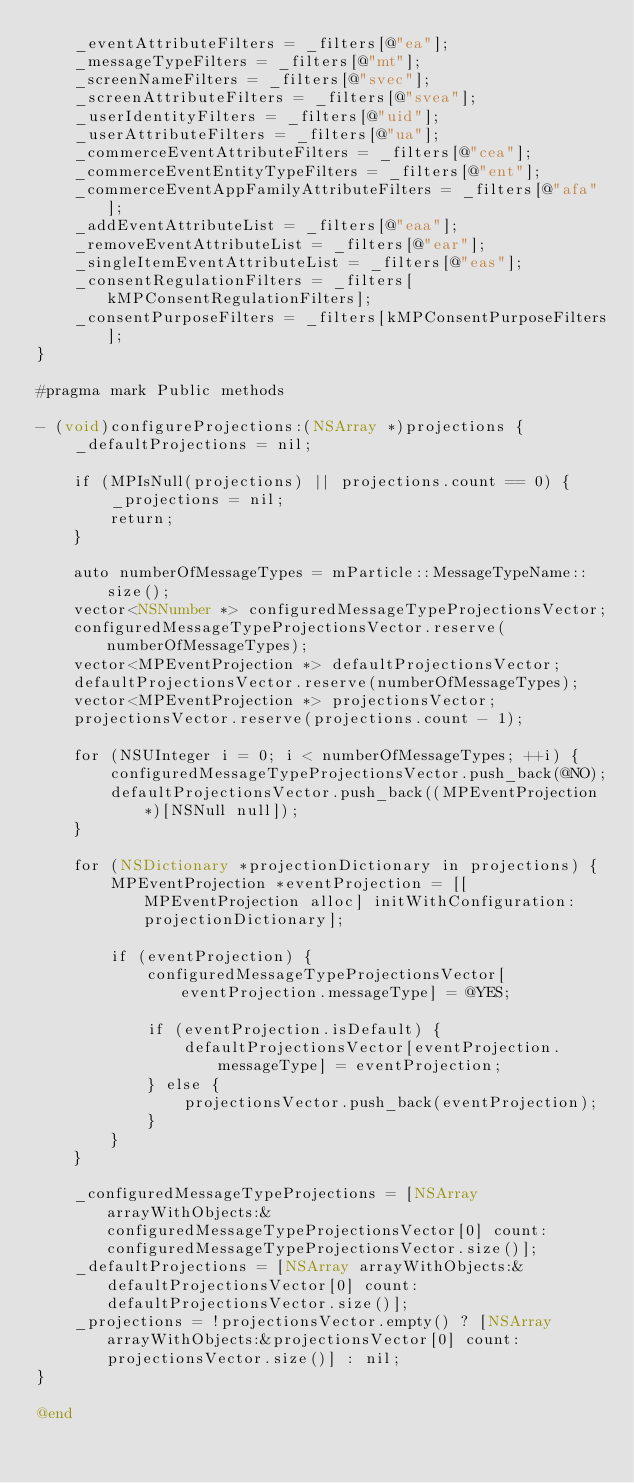Convert code to text. <code><loc_0><loc_0><loc_500><loc_500><_ObjectiveC_>    _eventAttributeFilters = _filters[@"ea"];
    _messageTypeFilters = _filters[@"mt"];
    _screenNameFilters = _filters[@"svec"];
    _screenAttributeFilters = _filters[@"svea"];
    _userIdentityFilters = _filters[@"uid"];
    _userAttributeFilters = _filters[@"ua"];
    _commerceEventAttributeFilters = _filters[@"cea"];
    _commerceEventEntityTypeFilters = _filters[@"ent"];
    _commerceEventAppFamilyAttributeFilters = _filters[@"afa"];
    _addEventAttributeList = _filters[@"eaa"];
    _removeEventAttributeList = _filters[@"ear"];
    _singleItemEventAttributeList = _filters[@"eas"];
    _consentRegulationFilters = _filters[kMPConsentRegulationFilters];
    _consentPurposeFilters = _filters[kMPConsentPurposeFilters];
}

#pragma mark Public methods

- (void)configureProjections:(NSArray *)projections {
    _defaultProjections = nil;
    
    if (MPIsNull(projections) || projections.count == 0) {
        _projections = nil;
        return;
    }
    
    auto numberOfMessageTypes = mParticle::MessageTypeName::size();
    vector<NSNumber *> configuredMessageTypeProjectionsVector;
    configuredMessageTypeProjectionsVector.reserve(numberOfMessageTypes);
    vector<MPEventProjection *> defaultProjectionsVector;
    defaultProjectionsVector.reserve(numberOfMessageTypes);
    vector<MPEventProjection *> projectionsVector;
    projectionsVector.reserve(projections.count - 1);
    
    for (NSUInteger i = 0; i < numberOfMessageTypes; ++i) {
        configuredMessageTypeProjectionsVector.push_back(@NO);
        defaultProjectionsVector.push_back((MPEventProjection *)[NSNull null]);
    }
    
    for (NSDictionary *projectionDictionary in projections) {
        MPEventProjection *eventProjection = [[MPEventProjection alloc] initWithConfiguration:projectionDictionary];
        
        if (eventProjection) {
            configuredMessageTypeProjectionsVector[eventProjection.messageType] = @YES;
            
            if (eventProjection.isDefault) {
                defaultProjectionsVector[eventProjection.messageType] = eventProjection;
            } else {
                projectionsVector.push_back(eventProjection);
            }
        }
    }
    
    _configuredMessageTypeProjections = [NSArray arrayWithObjects:&configuredMessageTypeProjectionsVector[0] count:configuredMessageTypeProjectionsVector.size()];
    _defaultProjections = [NSArray arrayWithObjects:&defaultProjectionsVector[0] count:defaultProjectionsVector.size()];
    _projections = !projectionsVector.empty() ? [NSArray arrayWithObjects:&projectionsVector[0] count:projectionsVector.size()] : nil;
}

@end
</code> 